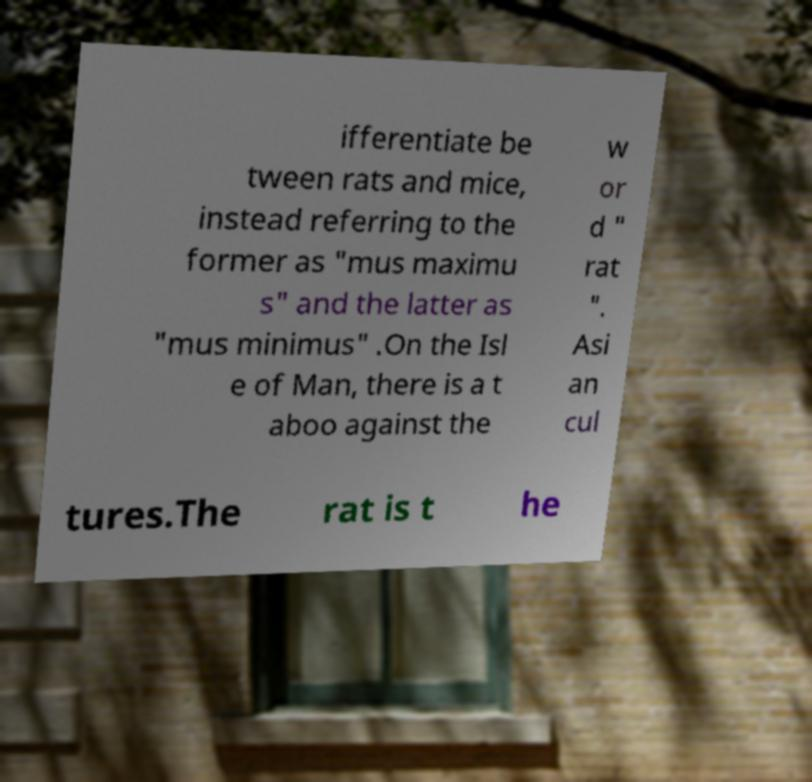Could you extract and type out the text from this image? ifferentiate be tween rats and mice, instead referring to the former as "mus maximu s" and the latter as "mus minimus" .On the Isl e of Man, there is a t aboo against the w or d " rat ". Asi an cul tures.The rat is t he 